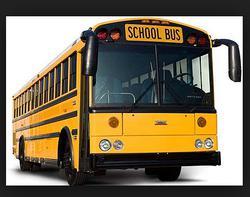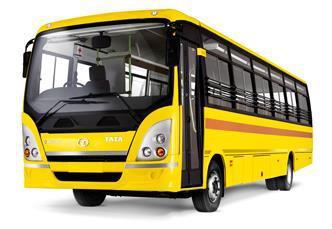The first image is the image on the left, the second image is the image on the right. For the images displayed, is the sentence "The left and right image contains the same number of buses with one facing right forward and the other facing left forward." factually correct? Answer yes or no. Yes. The first image is the image on the left, the second image is the image on the right. Given the left and right images, does the statement "Each image shows the front of a flat-fronted bus, and the buses depicted on the left and right are angled in opposite directions." hold true? Answer yes or no. Yes. 